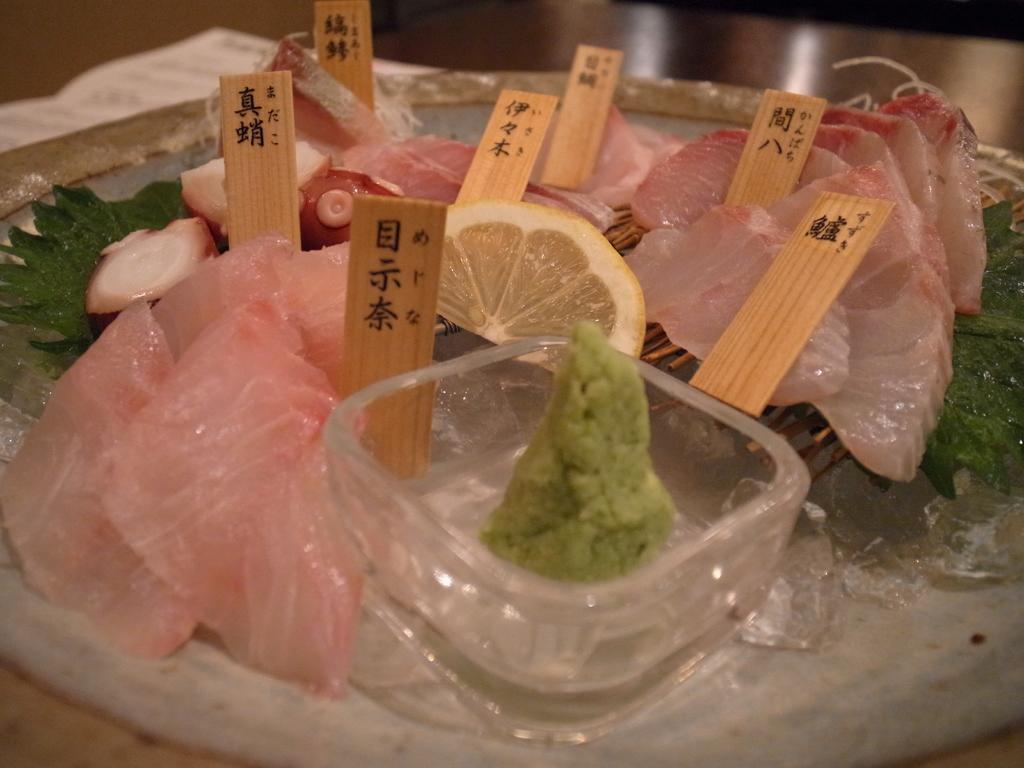In one or two sentences, can you explain what this image depicts? In this image we can see a food item on a surface, also we can see a glass bowl, in between food item, there are some sticks with some text written on it. 